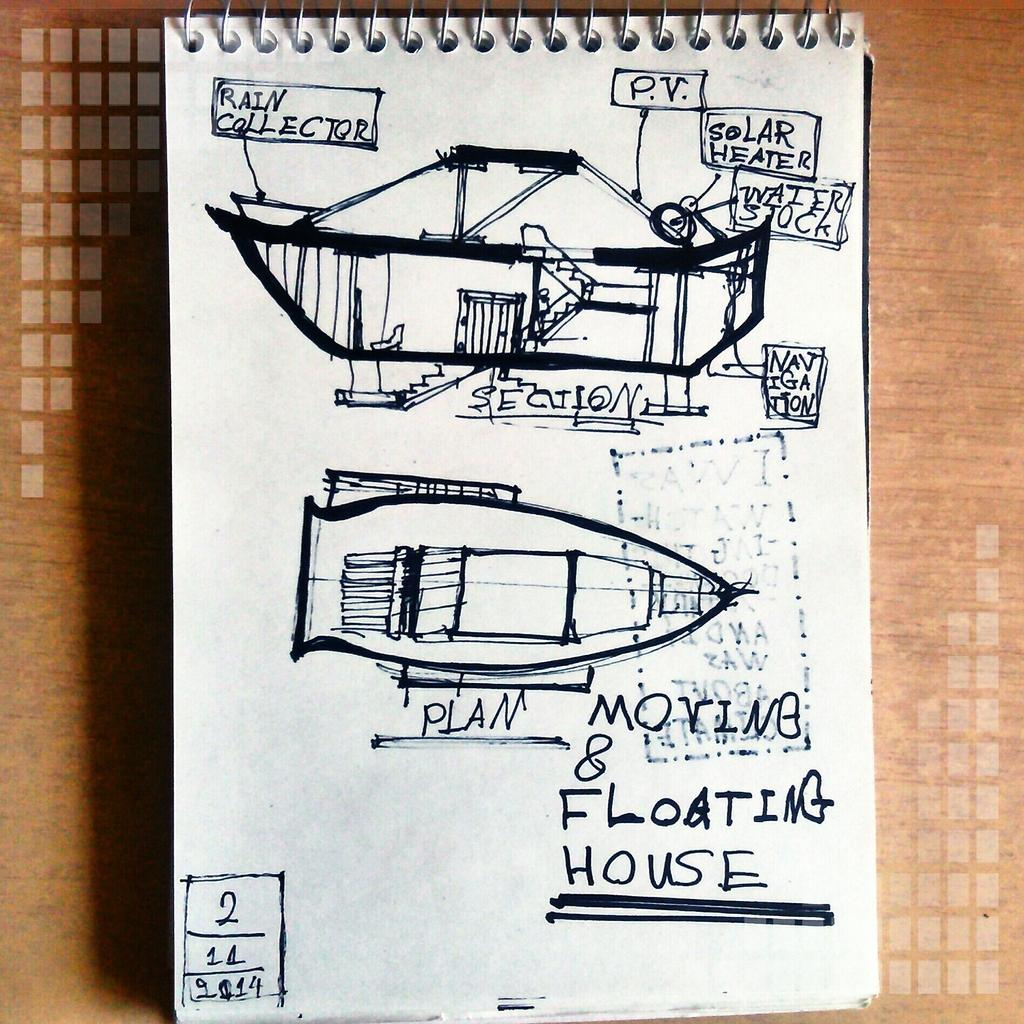What is depicted on the paper in the image? There is a sketch of a boat on the paper. How much of the boat can be seen in the sketch? Some parts of the boat are visible on the paper. What is the color of the surface the paper is placed on? The paper is placed on a brown color surface. Reasoning: Leting: Let's think step by step in order to produce the conversation. We start by identifying the main subject of the image, which is the sketch of a boat on the paper. Then, we describe the level of detail in the sketch by mentioning that some parts of the boat are visible. Finally, we note the color of the surface the paper is placed on, which is brown. Absurd Question/Answer: How much fuel is required for the boat in the image? There is no boat in the image, only a sketch of a boat on paper. What type of punishment is being given to the boat in the image? There is no boat or any indication of punishment in the image; it only shows a sketch of a boat on paper. How much fuel is required for the boat in the image? There is no boat in the image, only a sketch of a boat on paper. What type of punishment is being given to the boat in the image? There is no boat or any indication of punishment in the image; it only shows a sketch of a boat on paper. 